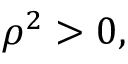Convert formula to latex. <formula><loc_0><loc_0><loc_500><loc_500>\rho ^ { 2 } > 0 ,</formula> 